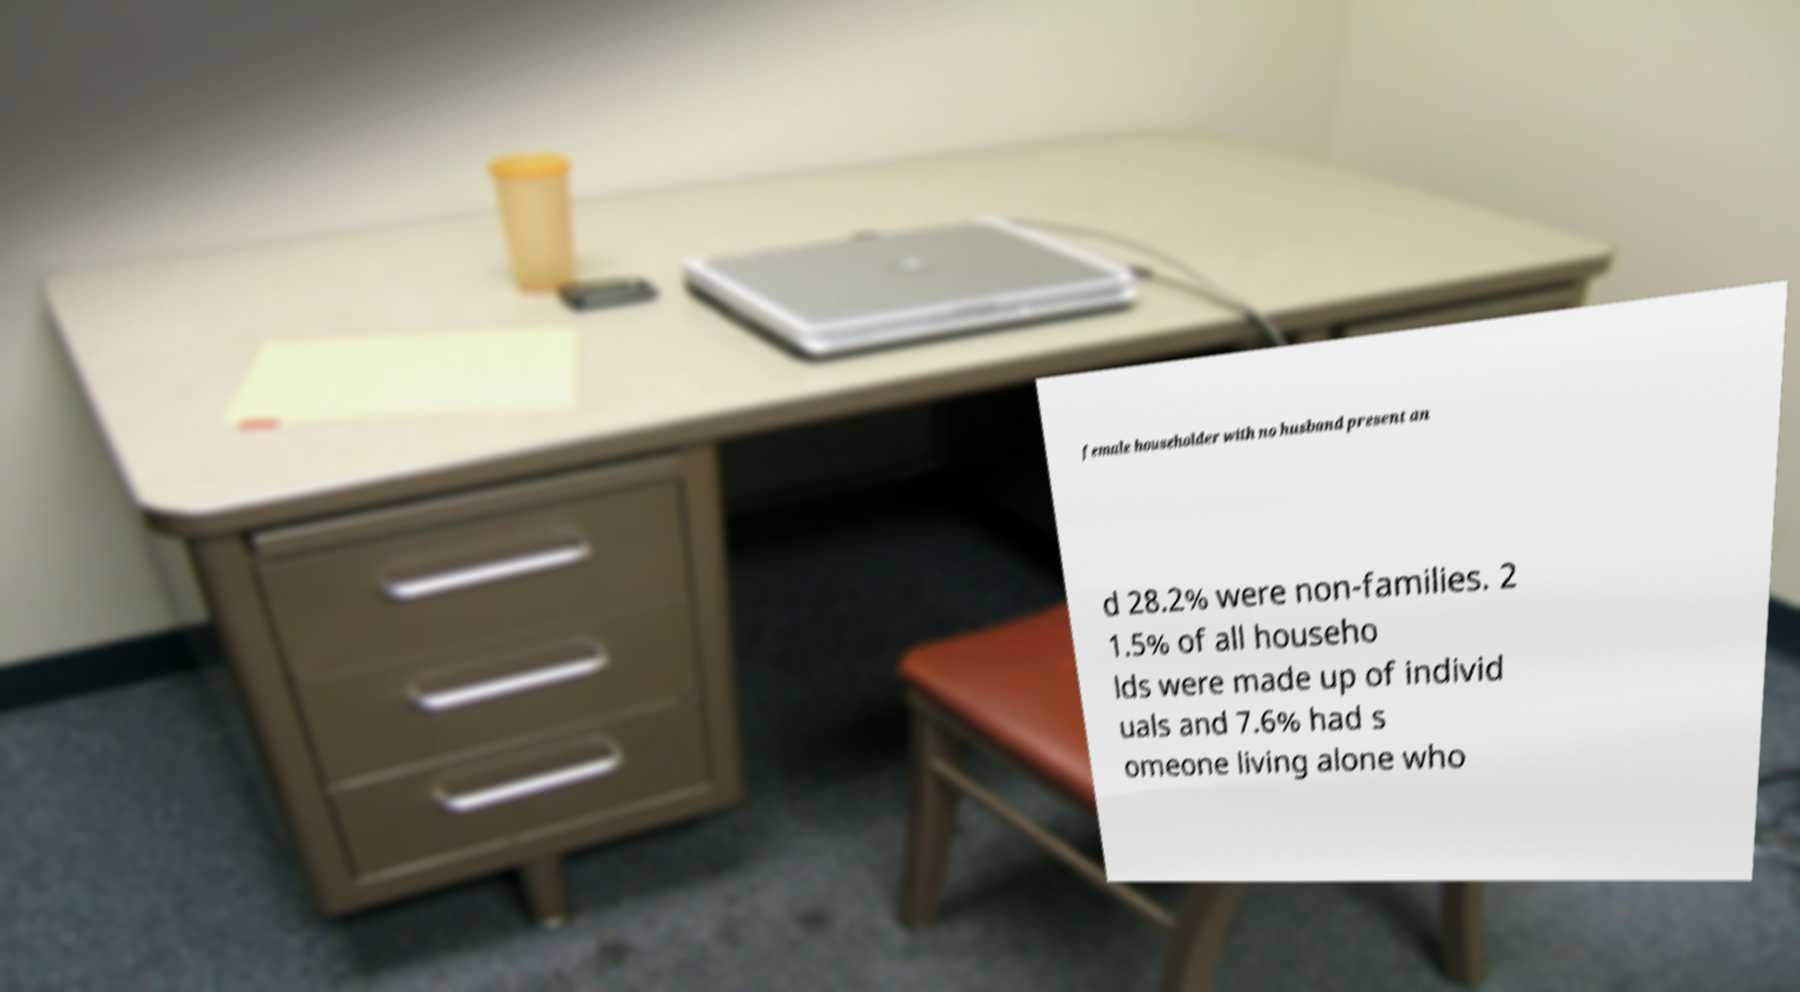Could you assist in decoding the text presented in this image and type it out clearly? female householder with no husband present an d 28.2% were non-families. 2 1.5% of all househo lds were made up of individ uals and 7.6% had s omeone living alone who 